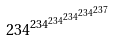<formula> <loc_0><loc_0><loc_500><loc_500>2 3 4 ^ { 2 3 4 ^ { 2 3 4 ^ { 2 3 4 ^ { 2 3 4 ^ { 2 3 7 } } } } }</formula> 